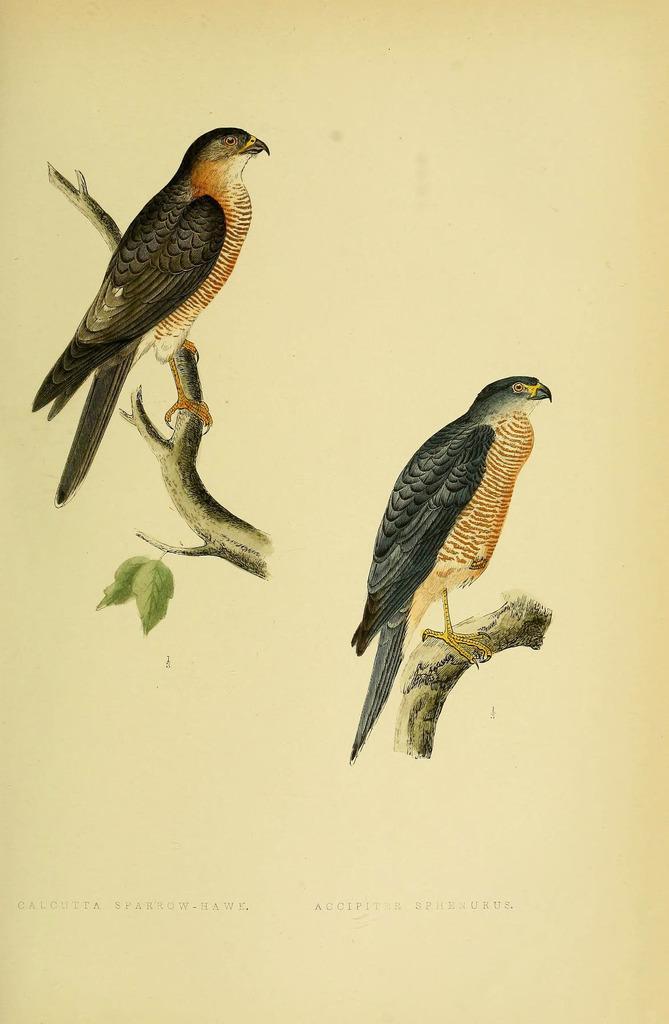Describe this image in one or two sentences. In this image I can see two birds which are grey, brown, orange, black and yellow in color are on the tree stems. I can see two leaves which are green in color and the cream colored background. 